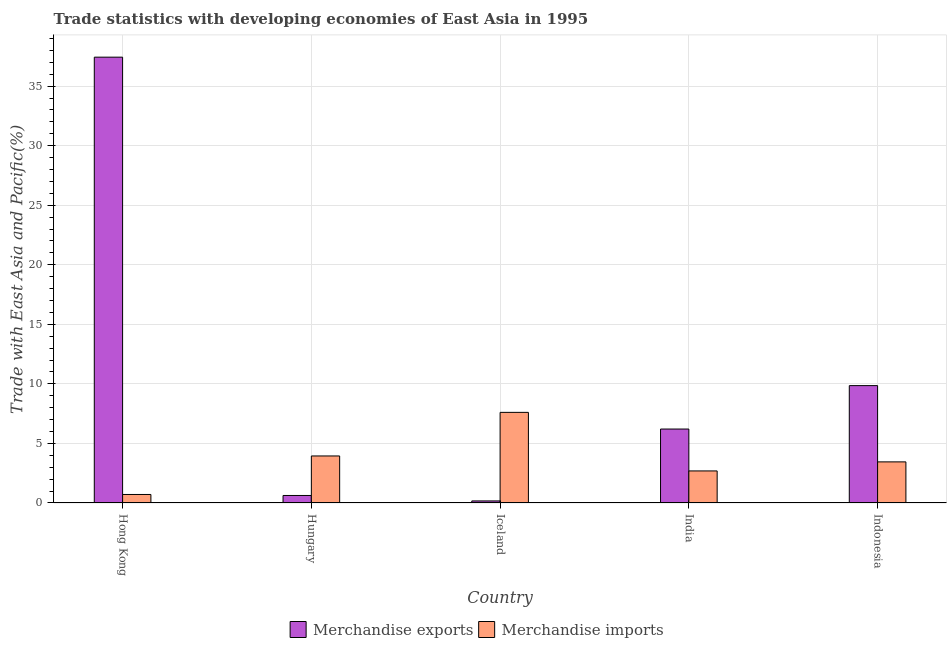How many groups of bars are there?
Your answer should be compact. 5. Are the number of bars per tick equal to the number of legend labels?
Keep it short and to the point. Yes. Are the number of bars on each tick of the X-axis equal?
Provide a succinct answer. Yes. How many bars are there on the 3rd tick from the left?
Provide a short and direct response. 2. What is the label of the 2nd group of bars from the left?
Keep it short and to the point. Hungary. In how many cases, is the number of bars for a given country not equal to the number of legend labels?
Offer a terse response. 0. What is the merchandise exports in Hong Kong?
Make the answer very short. 37.44. Across all countries, what is the maximum merchandise imports?
Your answer should be very brief. 7.61. Across all countries, what is the minimum merchandise exports?
Your answer should be compact. 0.17. In which country was the merchandise exports maximum?
Give a very brief answer. Hong Kong. In which country was the merchandise imports minimum?
Offer a terse response. Hong Kong. What is the total merchandise imports in the graph?
Ensure brevity in your answer.  18.42. What is the difference between the merchandise imports in Iceland and that in Indonesia?
Provide a succinct answer. 4.16. What is the difference between the merchandise imports in Indonesia and the merchandise exports in Hong Kong?
Offer a terse response. -33.98. What is the average merchandise imports per country?
Your response must be concise. 3.68. What is the difference between the merchandise imports and merchandise exports in India?
Your response must be concise. -3.52. What is the ratio of the merchandise exports in Hong Kong to that in Hungary?
Give a very brief answer. 59.37. Is the merchandise exports in Iceland less than that in India?
Your answer should be very brief. Yes. Is the difference between the merchandise exports in Hungary and India greater than the difference between the merchandise imports in Hungary and India?
Your response must be concise. No. What is the difference between the highest and the second highest merchandise imports?
Keep it short and to the point. 3.66. What is the difference between the highest and the lowest merchandise imports?
Keep it short and to the point. 6.89. In how many countries, is the merchandise exports greater than the average merchandise exports taken over all countries?
Keep it short and to the point. 1. How many countries are there in the graph?
Your answer should be very brief. 5. Are the values on the major ticks of Y-axis written in scientific E-notation?
Ensure brevity in your answer.  No. Does the graph contain grids?
Your answer should be very brief. Yes. Where does the legend appear in the graph?
Provide a succinct answer. Bottom center. How many legend labels are there?
Your response must be concise. 2. How are the legend labels stacked?
Give a very brief answer. Horizontal. What is the title of the graph?
Offer a very short reply. Trade statistics with developing economies of East Asia in 1995. Does "Forest land" appear as one of the legend labels in the graph?
Offer a very short reply. No. What is the label or title of the Y-axis?
Keep it short and to the point. Trade with East Asia and Pacific(%). What is the Trade with East Asia and Pacific(%) in Merchandise exports in Hong Kong?
Provide a succinct answer. 37.44. What is the Trade with East Asia and Pacific(%) of Merchandise imports in Hong Kong?
Provide a short and direct response. 0.72. What is the Trade with East Asia and Pacific(%) in Merchandise exports in Hungary?
Provide a succinct answer. 0.63. What is the Trade with East Asia and Pacific(%) in Merchandise imports in Hungary?
Offer a very short reply. 3.95. What is the Trade with East Asia and Pacific(%) of Merchandise exports in Iceland?
Your answer should be compact. 0.17. What is the Trade with East Asia and Pacific(%) of Merchandise imports in Iceland?
Provide a short and direct response. 7.61. What is the Trade with East Asia and Pacific(%) in Merchandise exports in India?
Offer a very short reply. 6.21. What is the Trade with East Asia and Pacific(%) of Merchandise imports in India?
Make the answer very short. 2.69. What is the Trade with East Asia and Pacific(%) of Merchandise exports in Indonesia?
Make the answer very short. 9.86. What is the Trade with East Asia and Pacific(%) in Merchandise imports in Indonesia?
Give a very brief answer. 3.45. Across all countries, what is the maximum Trade with East Asia and Pacific(%) in Merchandise exports?
Provide a short and direct response. 37.44. Across all countries, what is the maximum Trade with East Asia and Pacific(%) in Merchandise imports?
Offer a terse response. 7.61. Across all countries, what is the minimum Trade with East Asia and Pacific(%) in Merchandise exports?
Offer a terse response. 0.17. Across all countries, what is the minimum Trade with East Asia and Pacific(%) in Merchandise imports?
Your response must be concise. 0.72. What is the total Trade with East Asia and Pacific(%) in Merchandise exports in the graph?
Your response must be concise. 54.31. What is the total Trade with East Asia and Pacific(%) in Merchandise imports in the graph?
Your answer should be very brief. 18.42. What is the difference between the Trade with East Asia and Pacific(%) in Merchandise exports in Hong Kong and that in Hungary?
Your response must be concise. 36.81. What is the difference between the Trade with East Asia and Pacific(%) in Merchandise imports in Hong Kong and that in Hungary?
Provide a succinct answer. -3.23. What is the difference between the Trade with East Asia and Pacific(%) in Merchandise exports in Hong Kong and that in Iceland?
Provide a short and direct response. 37.26. What is the difference between the Trade with East Asia and Pacific(%) in Merchandise imports in Hong Kong and that in Iceland?
Give a very brief answer. -6.89. What is the difference between the Trade with East Asia and Pacific(%) in Merchandise exports in Hong Kong and that in India?
Your response must be concise. 31.23. What is the difference between the Trade with East Asia and Pacific(%) of Merchandise imports in Hong Kong and that in India?
Make the answer very short. -1.98. What is the difference between the Trade with East Asia and Pacific(%) of Merchandise exports in Hong Kong and that in Indonesia?
Ensure brevity in your answer.  27.58. What is the difference between the Trade with East Asia and Pacific(%) of Merchandise imports in Hong Kong and that in Indonesia?
Provide a succinct answer. -2.74. What is the difference between the Trade with East Asia and Pacific(%) in Merchandise exports in Hungary and that in Iceland?
Provide a succinct answer. 0.46. What is the difference between the Trade with East Asia and Pacific(%) of Merchandise imports in Hungary and that in Iceland?
Offer a very short reply. -3.66. What is the difference between the Trade with East Asia and Pacific(%) of Merchandise exports in Hungary and that in India?
Offer a very short reply. -5.58. What is the difference between the Trade with East Asia and Pacific(%) in Merchandise imports in Hungary and that in India?
Keep it short and to the point. 1.26. What is the difference between the Trade with East Asia and Pacific(%) in Merchandise exports in Hungary and that in Indonesia?
Keep it short and to the point. -9.22. What is the difference between the Trade with East Asia and Pacific(%) of Merchandise imports in Hungary and that in Indonesia?
Keep it short and to the point. 0.5. What is the difference between the Trade with East Asia and Pacific(%) in Merchandise exports in Iceland and that in India?
Ensure brevity in your answer.  -6.04. What is the difference between the Trade with East Asia and Pacific(%) in Merchandise imports in Iceland and that in India?
Ensure brevity in your answer.  4.92. What is the difference between the Trade with East Asia and Pacific(%) in Merchandise exports in Iceland and that in Indonesia?
Offer a terse response. -9.68. What is the difference between the Trade with East Asia and Pacific(%) of Merchandise imports in Iceland and that in Indonesia?
Ensure brevity in your answer.  4.16. What is the difference between the Trade with East Asia and Pacific(%) of Merchandise exports in India and that in Indonesia?
Make the answer very short. -3.65. What is the difference between the Trade with East Asia and Pacific(%) of Merchandise imports in India and that in Indonesia?
Offer a terse response. -0.76. What is the difference between the Trade with East Asia and Pacific(%) of Merchandise exports in Hong Kong and the Trade with East Asia and Pacific(%) of Merchandise imports in Hungary?
Ensure brevity in your answer.  33.49. What is the difference between the Trade with East Asia and Pacific(%) in Merchandise exports in Hong Kong and the Trade with East Asia and Pacific(%) in Merchandise imports in Iceland?
Offer a very short reply. 29.83. What is the difference between the Trade with East Asia and Pacific(%) in Merchandise exports in Hong Kong and the Trade with East Asia and Pacific(%) in Merchandise imports in India?
Your answer should be compact. 34.74. What is the difference between the Trade with East Asia and Pacific(%) in Merchandise exports in Hong Kong and the Trade with East Asia and Pacific(%) in Merchandise imports in Indonesia?
Offer a very short reply. 33.98. What is the difference between the Trade with East Asia and Pacific(%) of Merchandise exports in Hungary and the Trade with East Asia and Pacific(%) of Merchandise imports in Iceland?
Your answer should be very brief. -6.98. What is the difference between the Trade with East Asia and Pacific(%) in Merchandise exports in Hungary and the Trade with East Asia and Pacific(%) in Merchandise imports in India?
Your response must be concise. -2.06. What is the difference between the Trade with East Asia and Pacific(%) of Merchandise exports in Hungary and the Trade with East Asia and Pacific(%) of Merchandise imports in Indonesia?
Make the answer very short. -2.82. What is the difference between the Trade with East Asia and Pacific(%) of Merchandise exports in Iceland and the Trade with East Asia and Pacific(%) of Merchandise imports in India?
Keep it short and to the point. -2.52. What is the difference between the Trade with East Asia and Pacific(%) of Merchandise exports in Iceland and the Trade with East Asia and Pacific(%) of Merchandise imports in Indonesia?
Offer a terse response. -3.28. What is the difference between the Trade with East Asia and Pacific(%) of Merchandise exports in India and the Trade with East Asia and Pacific(%) of Merchandise imports in Indonesia?
Provide a succinct answer. 2.76. What is the average Trade with East Asia and Pacific(%) in Merchandise exports per country?
Your answer should be compact. 10.86. What is the average Trade with East Asia and Pacific(%) in Merchandise imports per country?
Your answer should be compact. 3.68. What is the difference between the Trade with East Asia and Pacific(%) of Merchandise exports and Trade with East Asia and Pacific(%) of Merchandise imports in Hong Kong?
Your response must be concise. 36.72. What is the difference between the Trade with East Asia and Pacific(%) in Merchandise exports and Trade with East Asia and Pacific(%) in Merchandise imports in Hungary?
Provide a short and direct response. -3.32. What is the difference between the Trade with East Asia and Pacific(%) of Merchandise exports and Trade with East Asia and Pacific(%) of Merchandise imports in Iceland?
Offer a very short reply. -7.44. What is the difference between the Trade with East Asia and Pacific(%) in Merchandise exports and Trade with East Asia and Pacific(%) in Merchandise imports in India?
Offer a terse response. 3.52. What is the difference between the Trade with East Asia and Pacific(%) in Merchandise exports and Trade with East Asia and Pacific(%) in Merchandise imports in Indonesia?
Give a very brief answer. 6.4. What is the ratio of the Trade with East Asia and Pacific(%) of Merchandise exports in Hong Kong to that in Hungary?
Your response must be concise. 59.37. What is the ratio of the Trade with East Asia and Pacific(%) in Merchandise imports in Hong Kong to that in Hungary?
Give a very brief answer. 0.18. What is the ratio of the Trade with East Asia and Pacific(%) in Merchandise exports in Hong Kong to that in Iceland?
Keep it short and to the point. 215.78. What is the ratio of the Trade with East Asia and Pacific(%) of Merchandise imports in Hong Kong to that in Iceland?
Offer a terse response. 0.09. What is the ratio of the Trade with East Asia and Pacific(%) of Merchandise exports in Hong Kong to that in India?
Provide a succinct answer. 6.03. What is the ratio of the Trade with East Asia and Pacific(%) in Merchandise imports in Hong Kong to that in India?
Your answer should be compact. 0.27. What is the ratio of the Trade with East Asia and Pacific(%) of Merchandise exports in Hong Kong to that in Indonesia?
Provide a succinct answer. 3.8. What is the ratio of the Trade with East Asia and Pacific(%) of Merchandise imports in Hong Kong to that in Indonesia?
Ensure brevity in your answer.  0.21. What is the ratio of the Trade with East Asia and Pacific(%) in Merchandise exports in Hungary to that in Iceland?
Give a very brief answer. 3.63. What is the ratio of the Trade with East Asia and Pacific(%) of Merchandise imports in Hungary to that in Iceland?
Offer a terse response. 0.52. What is the ratio of the Trade with East Asia and Pacific(%) of Merchandise exports in Hungary to that in India?
Your answer should be compact. 0.1. What is the ratio of the Trade with East Asia and Pacific(%) in Merchandise imports in Hungary to that in India?
Your answer should be very brief. 1.47. What is the ratio of the Trade with East Asia and Pacific(%) in Merchandise exports in Hungary to that in Indonesia?
Give a very brief answer. 0.06. What is the ratio of the Trade with East Asia and Pacific(%) in Merchandise imports in Hungary to that in Indonesia?
Your response must be concise. 1.14. What is the ratio of the Trade with East Asia and Pacific(%) in Merchandise exports in Iceland to that in India?
Your answer should be very brief. 0.03. What is the ratio of the Trade with East Asia and Pacific(%) in Merchandise imports in Iceland to that in India?
Make the answer very short. 2.83. What is the ratio of the Trade with East Asia and Pacific(%) of Merchandise exports in Iceland to that in Indonesia?
Ensure brevity in your answer.  0.02. What is the ratio of the Trade with East Asia and Pacific(%) in Merchandise imports in Iceland to that in Indonesia?
Your response must be concise. 2.2. What is the ratio of the Trade with East Asia and Pacific(%) in Merchandise exports in India to that in Indonesia?
Your answer should be compact. 0.63. What is the ratio of the Trade with East Asia and Pacific(%) of Merchandise imports in India to that in Indonesia?
Make the answer very short. 0.78. What is the difference between the highest and the second highest Trade with East Asia and Pacific(%) of Merchandise exports?
Your answer should be very brief. 27.58. What is the difference between the highest and the second highest Trade with East Asia and Pacific(%) in Merchandise imports?
Keep it short and to the point. 3.66. What is the difference between the highest and the lowest Trade with East Asia and Pacific(%) in Merchandise exports?
Keep it short and to the point. 37.26. What is the difference between the highest and the lowest Trade with East Asia and Pacific(%) in Merchandise imports?
Provide a short and direct response. 6.89. 